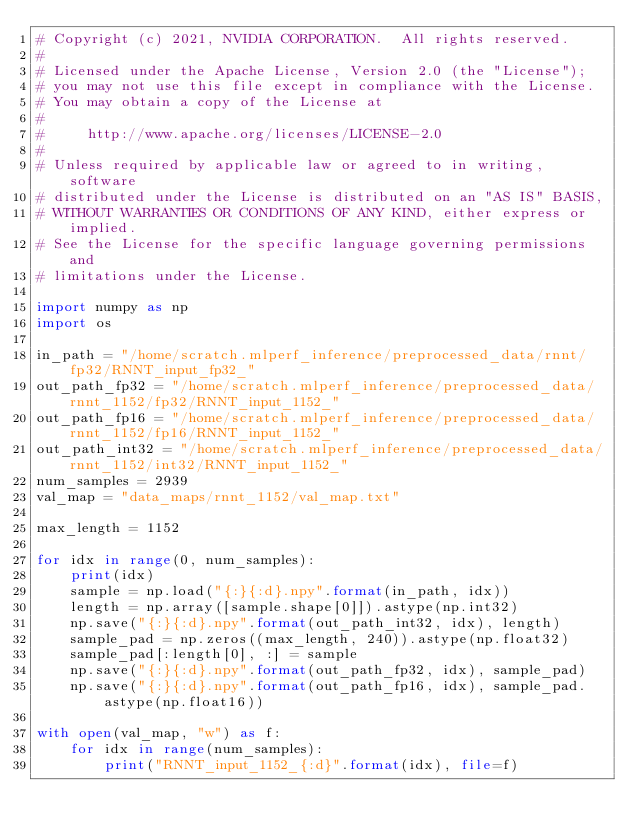<code> <loc_0><loc_0><loc_500><loc_500><_Python_># Copyright (c) 2021, NVIDIA CORPORATION.  All rights reserved.
#
# Licensed under the Apache License, Version 2.0 (the "License");
# you may not use this file except in compliance with the License.
# You may obtain a copy of the License at
#
#     http://www.apache.org/licenses/LICENSE-2.0
#
# Unless required by applicable law or agreed to in writing, software
# distributed under the License is distributed on an "AS IS" BASIS,
# WITHOUT WARRANTIES OR CONDITIONS OF ANY KIND, either express or implied.
# See the License for the specific language governing permissions and
# limitations under the License.

import numpy as np
import os

in_path = "/home/scratch.mlperf_inference/preprocessed_data/rnnt/fp32/RNNT_input_fp32_"
out_path_fp32 = "/home/scratch.mlperf_inference/preprocessed_data/rnnt_1152/fp32/RNNT_input_1152_"
out_path_fp16 = "/home/scratch.mlperf_inference/preprocessed_data/rnnt_1152/fp16/RNNT_input_1152_"
out_path_int32 = "/home/scratch.mlperf_inference/preprocessed_data/rnnt_1152/int32/RNNT_input_1152_"
num_samples = 2939
val_map = "data_maps/rnnt_1152/val_map.txt"

max_length = 1152

for idx in range(0, num_samples):
    print(idx)
    sample = np.load("{:}{:d}.npy".format(in_path, idx))
    length = np.array([sample.shape[0]]).astype(np.int32)
    np.save("{:}{:d}.npy".format(out_path_int32, idx), length)
    sample_pad = np.zeros((max_length, 240)).astype(np.float32)
    sample_pad[:length[0], :] = sample
    np.save("{:}{:d}.npy".format(out_path_fp32, idx), sample_pad)
    np.save("{:}{:d}.npy".format(out_path_fp16, idx), sample_pad.astype(np.float16))

with open(val_map, "w") as f:
    for idx in range(num_samples):
        print("RNNT_input_1152_{:d}".format(idx), file=f)
</code> 